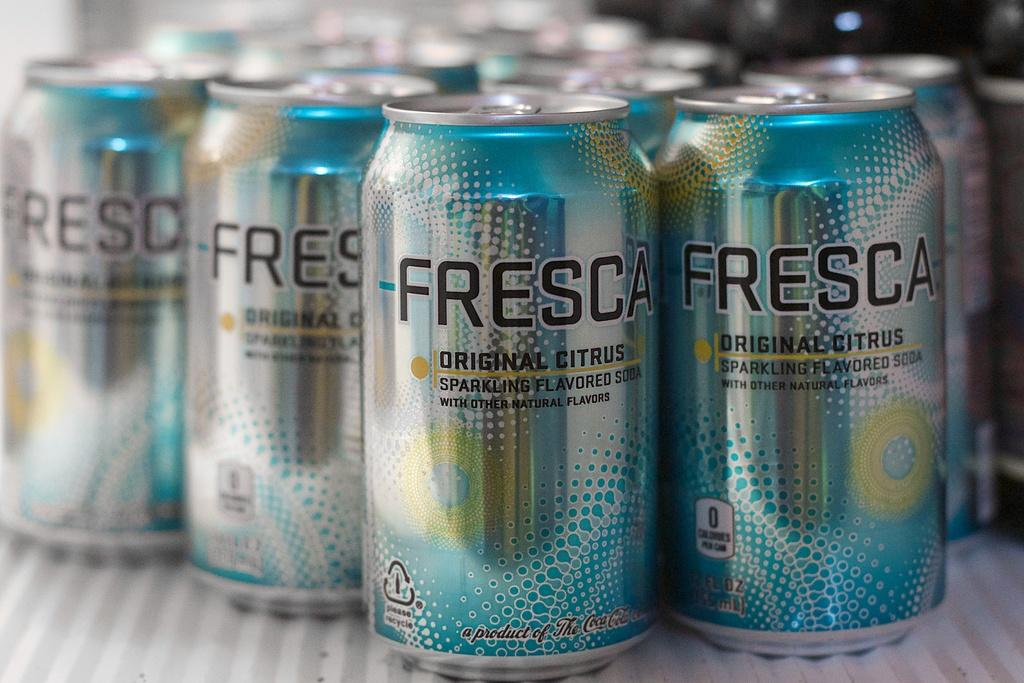<image>
Share a concise interpretation of the image provided. A group of Fresca cans has original citrus on it. 